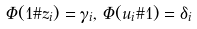<formula> <loc_0><loc_0><loc_500><loc_500>\Phi ( 1 { \# } z _ { i } ) = \gamma _ { i } , \, \Phi ( u _ { i } { \# } 1 ) = \delta _ { i }</formula> 